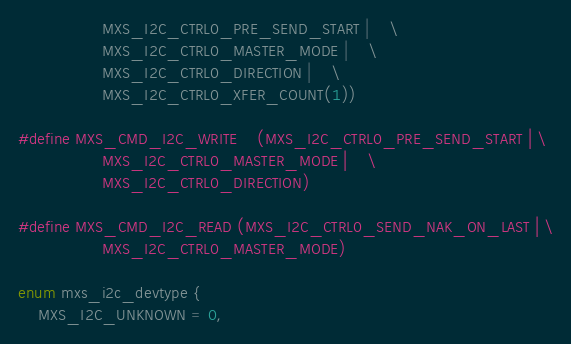<code> <loc_0><loc_0><loc_500><loc_500><_C_>				 MXS_I2C_CTRL0_PRE_SEND_START |	\
				 MXS_I2C_CTRL0_MASTER_MODE |	\
				 MXS_I2C_CTRL0_DIRECTION |	\
				 MXS_I2C_CTRL0_XFER_COUNT(1))

#define MXS_CMD_I2C_WRITE	(MXS_I2C_CTRL0_PRE_SEND_START |	\
				 MXS_I2C_CTRL0_MASTER_MODE |	\
				 MXS_I2C_CTRL0_DIRECTION)

#define MXS_CMD_I2C_READ	(MXS_I2C_CTRL0_SEND_NAK_ON_LAST | \
				 MXS_I2C_CTRL0_MASTER_MODE)

enum mxs_i2c_devtype {
	MXS_I2C_UNKNOWN = 0,</code> 